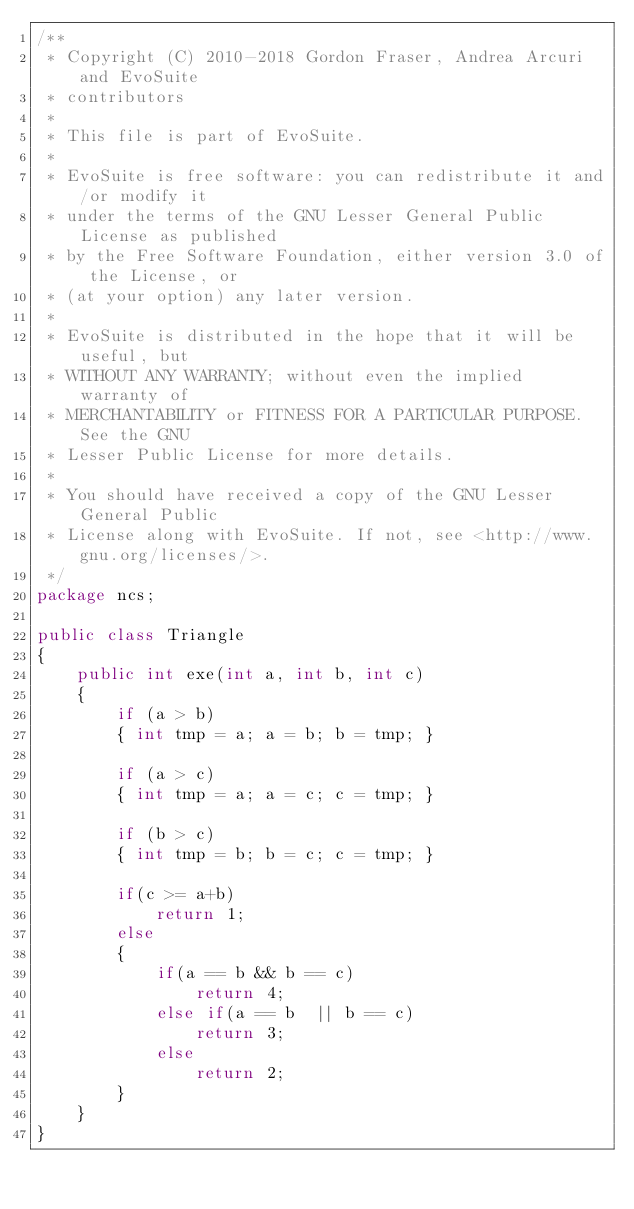Convert code to text. <code><loc_0><loc_0><loc_500><loc_500><_Java_>/**
 * Copyright (C) 2010-2018 Gordon Fraser, Andrea Arcuri and EvoSuite
 * contributors
 *
 * This file is part of EvoSuite.
 *
 * EvoSuite is free software: you can redistribute it and/or modify it
 * under the terms of the GNU Lesser General Public License as published
 * by the Free Software Foundation, either version 3.0 of the License, or
 * (at your option) any later version.
 *
 * EvoSuite is distributed in the hope that it will be useful, but
 * WITHOUT ANY WARRANTY; without even the implied warranty of
 * MERCHANTABILITY or FITNESS FOR A PARTICULAR PURPOSE. See the GNU
 * Lesser Public License for more details.
 *
 * You should have received a copy of the GNU Lesser General Public
 * License along with EvoSuite. If not, see <http://www.gnu.org/licenses/>.
 */
package ncs;

public class Triangle
{
	public int exe(int a, int b, int c)  
	{
		if (a > b) 
		{ int tmp = a; a = b; b = tmp; }

		if (a > c) 
		{ int tmp = a; a = c; c = tmp; }

		if (b > c) 
		{ int tmp = b; b = c; c = tmp; }

		if(c >= a+b)
			return 1;
		else
		{
			if(a == b && b == c)
				return 4;
			else if(a == b  || b == c)
				return 3;
			else
				return 2;
		}
	}	
}</code> 